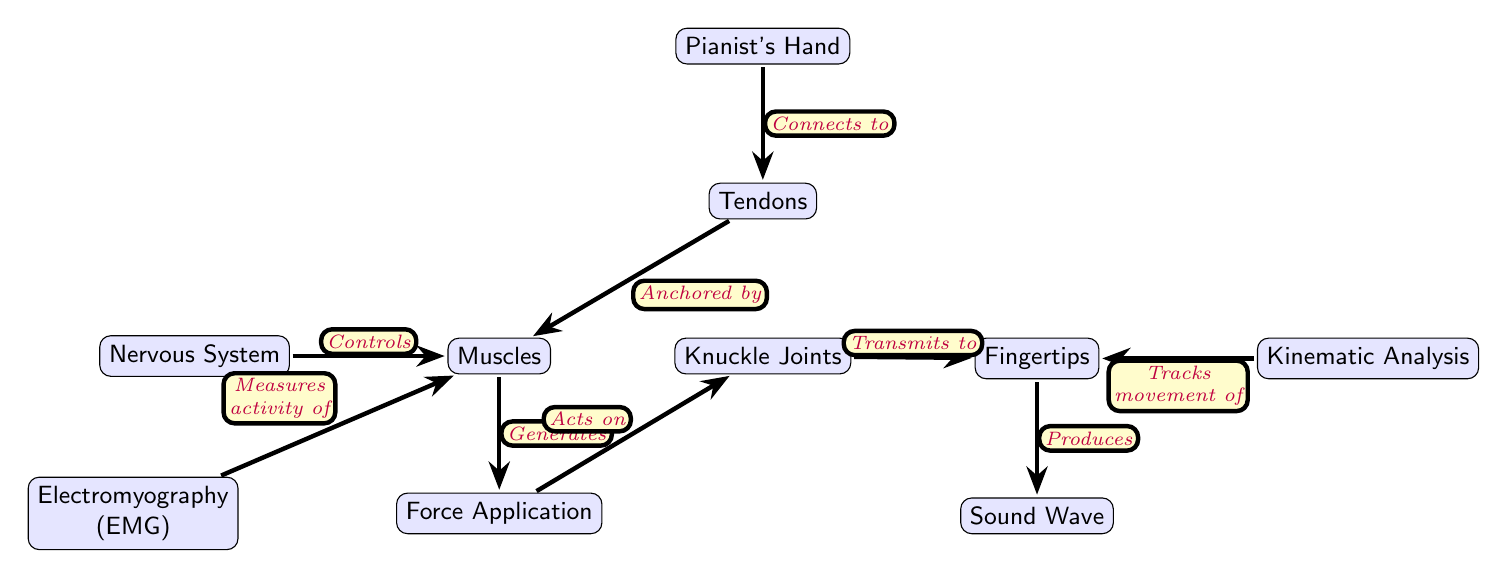What's the total number of nodes in the diagram? By inspecting the diagram, we can count all the distinct nodes present, which includes: "Pianist's Hand," "Tendons," "Muscles," "Fingertips," "Knuckle Joints," "Nervous System," "Force Application," "Electromyography," "Kinematic Analysis," and "Sound Wave." This totals to 10 nodes.
Answer: 10 What connects to "Tendons"? The edge labeled "Connects to" leads from "Pianist's Hand" to "Tendons," indicating that the pianist's hand directly connects to the tendons.
Answer: Pianist's Hand How are "Muscles" and "Force Application" related? The diagram shows a direct edge from "Muscles" to "Force Application" labeled "Generates." This indicates that the muscles generate the force that is then applied.
Answer: Generates Which node measures the activity of "Muscles"? The edge leading from "Electromyography" to "Muscles" is labeled "Measures activity of," meaning electromyography is the tool that measures muscle activity.
Answer: Electromyography What effect does "Force Application" have on "Knuckle Joints"? The diagram indicates that "Force Application" "Acts on" the "Knuckle Joints." This means that the force applied by the muscles directly affects the knuckle joints' movement and function.
Answer: Acts on Which node controls the "Muscles"? The edge from "Nervous System" to "Muscles" is labeled "Controls," showing that the nervous system has a regulatory role over muscle function.
Answer: Nervous System How does the "Fingertips" produce "Sound Wave"? The "Fingertips" have an edge directed to "Sound Wave," labeled "Produces," indicating that the interaction and movement at the fingertips result in the production of sound waves when playing the piano.
Answer: Produces What tracks the movement of "Fingertips"? The edge from "Kinematic Analysis" to "Fingertip" is labeled "Tracks movement of," suggesting that kinematic analysis is responsible for monitoring or analyzing the movements of the fingertips during performance.
Answer: Tracks movement of Describe the flow of information from "Nervous System" to "Sound Wave." Starting from the "Nervous System," it controls the "Muscles," which generate a force that is applied to the "Knuckle Joints." The joints then transmit this force to the "Fingertips," which ultimately produce a "Sound Wave." This shows a clear pathway of control leading to sound production.
Answer: Nervous System to Muscles to Force Application to Knuckle Joints to Fingertips to Sound Wave 